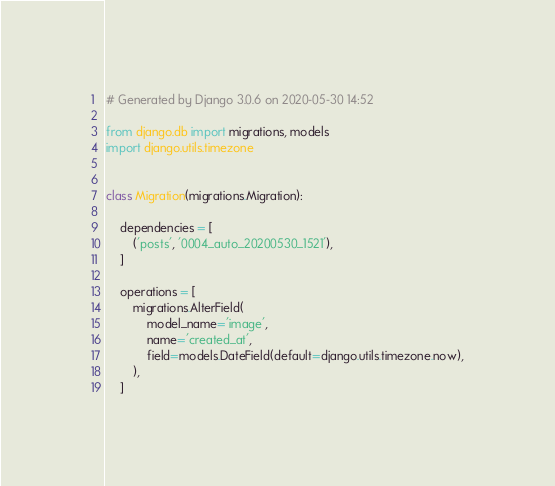<code> <loc_0><loc_0><loc_500><loc_500><_Python_># Generated by Django 3.0.6 on 2020-05-30 14:52

from django.db import migrations, models
import django.utils.timezone


class Migration(migrations.Migration):

    dependencies = [
        ('posts', '0004_auto_20200530_1521'),
    ]

    operations = [
        migrations.AlterField(
            model_name='image',
            name='created_at',
            field=models.DateField(default=django.utils.timezone.now),
        ),
    ]
</code> 